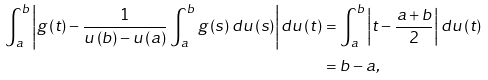Convert formula to latex. <formula><loc_0><loc_0><loc_500><loc_500>\int _ { a } ^ { b } \left | g \left ( t \right ) - \frac { 1 } { u \left ( b \right ) - u \left ( a \right ) } \int _ { a } ^ { b } g \left ( s \right ) d u \left ( s \right ) \right | d u \left ( t \right ) & = \int _ { a } ^ { b } \left | t - \frac { a + b } { 2 } \right | d u \left ( t \right ) \\ & = b - a ,</formula> 